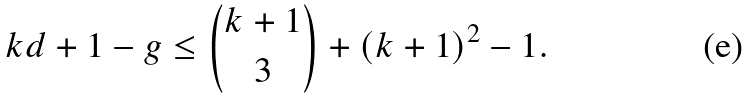Convert formula to latex. <formula><loc_0><loc_0><loc_500><loc_500>k d + 1 - g \leq \binom { k + 1 } { 3 } + ( k + 1 ) ^ { 2 } - 1 .</formula> 